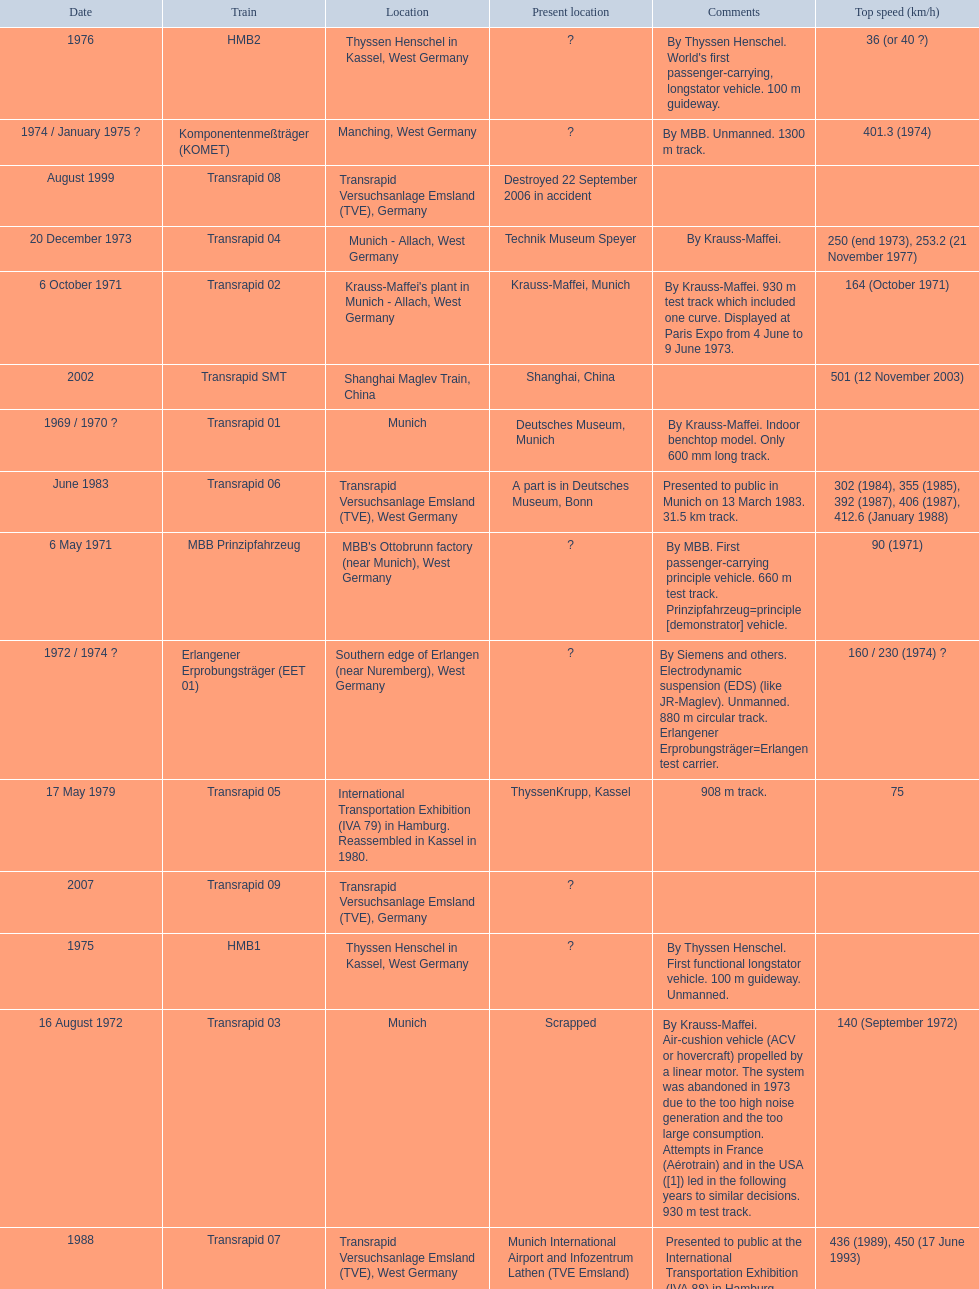What is the number of trains that were either scrapped or destroyed? 2. I'm looking to parse the entire table for insights. Could you assist me with that? {'header': ['Date', 'Train', 'Location', 'Present location', 'Comments', 'Top speed (km/h)'], 'rows': [['1976', 'HMB2', 'Thyssen Henschel in Kassel, West Germany', '?', "By Thyssen Henschel. World's first passenger-carrying, longstator vehicle. 100 m guideway.", '36 (or 40\xa0?)'], ['1974 / January 1975\xa0?', 'Komponentenmeßträger (KOMET)', 'Manching, West Germany', '?', 'By MBB. Unmanned. 1300 m track.', '401.3 (1974)'], ['August 1999', 'Transrapid 08', 'Transrapid Versuchsanlage Emsland (TVE), Germany', 'Destroyed 22 September 2006 in accident', '', ''], ['20 December 1973', 'Transrapid 04', 'Munich - Allach, West Germany', 'Technik Museum Speyer', 'By Krauss-Maffei.', '250 (end 1973), 253.2 (21 November 1977)'], ['6 October 1971', 'Transrapid 02', "Krauss-Maffei's plant in Munich - Allach, West Germany", 'Krauss-Maffei, Munich', 'By Krauss-Maffei. 930 m test track which included one curve. Displayed at Paris Expo from 4 June to 9 June 1973.', '164 (October 1971)'], ['2002', 'Transrapid SMT', 'Shanghai Maglev Train, China', 'Shanghai, China', '', '501 (12 November 2003)'], ['1969 / 1970\xa0?', 'Transrapid 01', 'Munich', 'Deutsches Museum, Munich', 'By Krauss-Maffei. Indoor benchtop model. Only 600\xa0mm long track.', ''], ['June 1983', 'Transrapid 06', 'Transrapid Versuchsanlage Emsland (TVE), West Germany', 'A part is in Deutsches Museum, Bonn', 'Presented to public in Munich on 13 March 1983. 31.5\xa0km track.', '302 (1984), 355 (1985), 392 (1987), 406 (1987), 412.6 (January 1988)'], ['6 May 1971', 'MBB Prinzipfahrzeug', "MBB's Ottobrunn factory (near Munich), West Germany", '?', 'By MBB. First passenger-carrying principle vehicle. 660 m test track. Prinzipfahrzeug=principle [demonstrator] vehicle.', '90 (1971)'], ['1972 / 1974\xa0?', 'Erlangener Erprobungsträger (EET 01)', 'Southern edge of Erlangen (near Nuremberg), West Germany', '?', 'By Siemens and others. Electrodynamic suspension (EDS) (like JR-Maglev). Unmanned. 880 m circular track. Erlangener Erprobungsträger=Erlangen test carrier.', '160 / 230 (1974)\xa0?'], ['17 May 1979', 'Transrapid 05', 'International Transportation Exhibition (IVA 79) in Hamburg. Reassembled in Kassel in 1980.', 'ThyssenKrupp, Kassel', '908 m track.', '75'], ['2007', 'Transrapid 09', 'Transrapid Versuchsanlage Emsland (TVE), Germany', '?', '', ''], ['1975', 'HMB1', 'Thyssen Henschel in Kassel, West Germany', '?', 'By Thyssen Henschel. First functional longstator vehicle. 100 m guideway. Unmanned.', ''], ['16 August 1972', 'Transrapid 03', 'Munich', 'Scrapped', 'By Krauss-Maffei. Air-cushion vehicle (ACV or hovercraft) propelled by a linear motor. The system was abandoned in 1973 due to the too high noise generation and the too large consumption. Attempts in France (Aérotrain) and in the USA ([1]) led in the following years to similar decisions. 930 m test track.', '140 (September 1972)'], ['1988', 'Transrapid 07', 'Transrapid Versuchsanlage Emsland (TVE), West Germany', 'Munich International Airport and Infozentrum Lathen (TVE Emsland)', 'Presented to public at the International Transportation Exhibition (IVA 88) in Hamburg.', '436 (1989), 450 (17 June 1993)']]} 